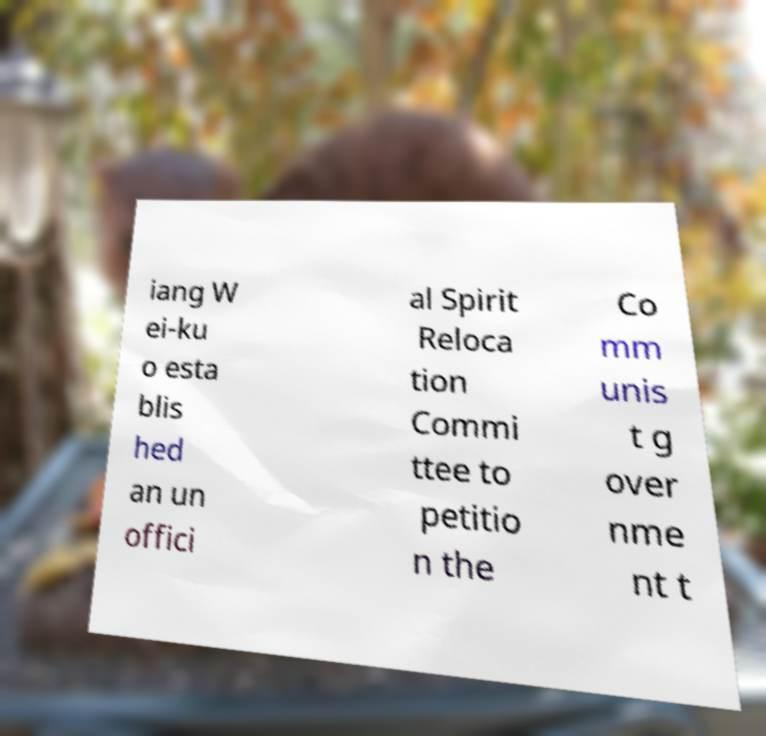Could you assist in decoding the text presented in this image and type it out clearly? iang W ei-ku o esta blis hed an un offici al Spirit Reloca tion Commi ttee to petitio n the Co mm unis t g over nme nt t 